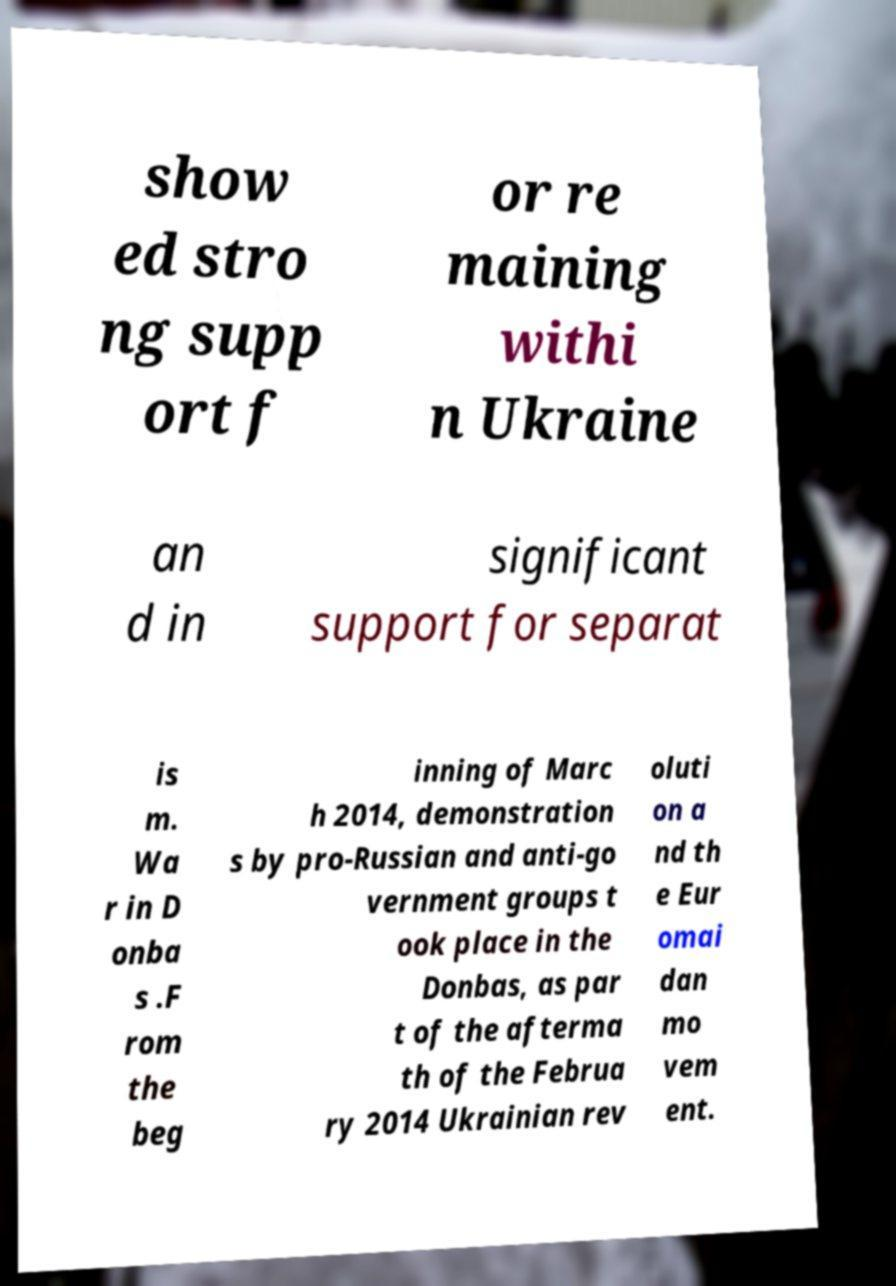Can you read and provide the text displayed in the image?This photo seems to have some interesting text. Can you extract and type it out for me? show ed stro ng supp ort f or re maining withi n Ukraine an d in significant support for separat is m. Wa r in D onba s .F rom the beg inning of Marc h 2014, demonstration s by pro-Russian and anti-go vernment groups t ook place in the Donbas, as par t of the afterma th of the Februa ry 2014 Ukrainian rev oluti on a nd th e Eur omai dan mo vem ent. 